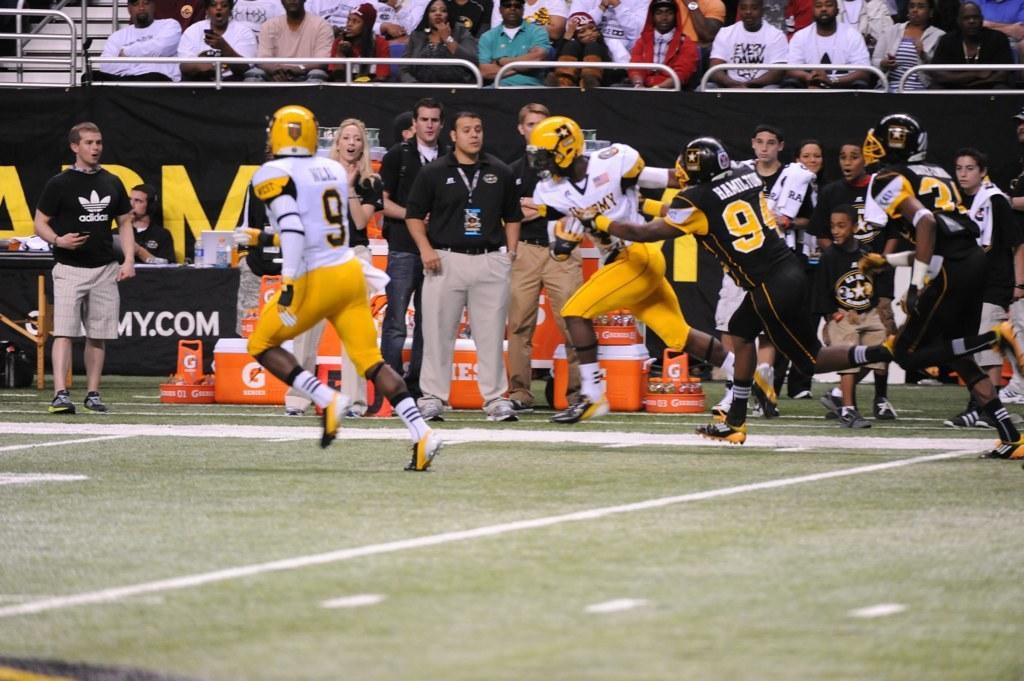In one or two sentences, can you explain what this image depicts? In this image I can see a ground in the front and on it I can see few people are running. In the background I can see many more people, few boards and number of orange colour things. I can also see something is written in the background and I can also see white lines on the ground. 